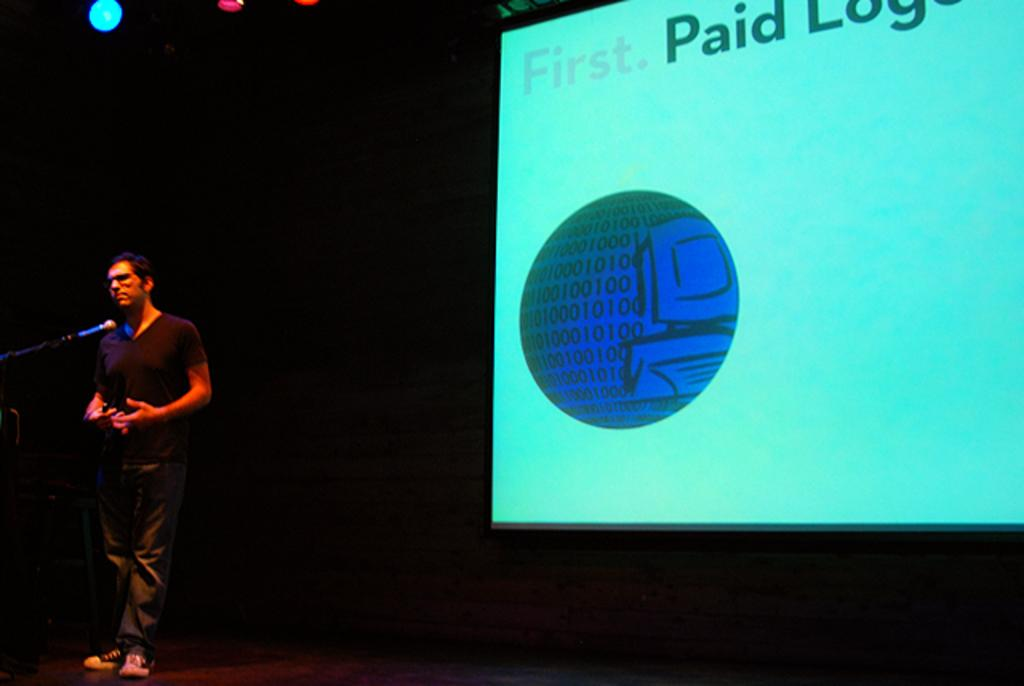What is the man in the image doing? The man is standing on the stage. Where is the man located in the image? The man is on the left side of the image. What is the man holding in the image? There is a microphone (mike) in the image. What can be seen in the background of the image? There are lights and a screen in the background of the image. What type of bone is the man holding in the image? There is no bone present in the image; the man is holding a microphone. 